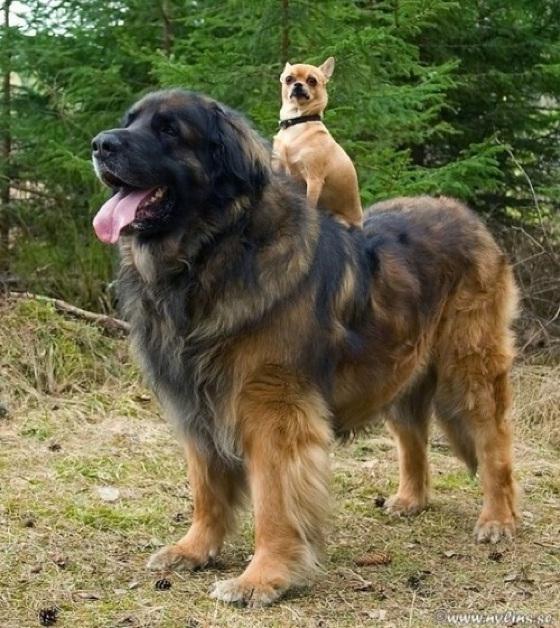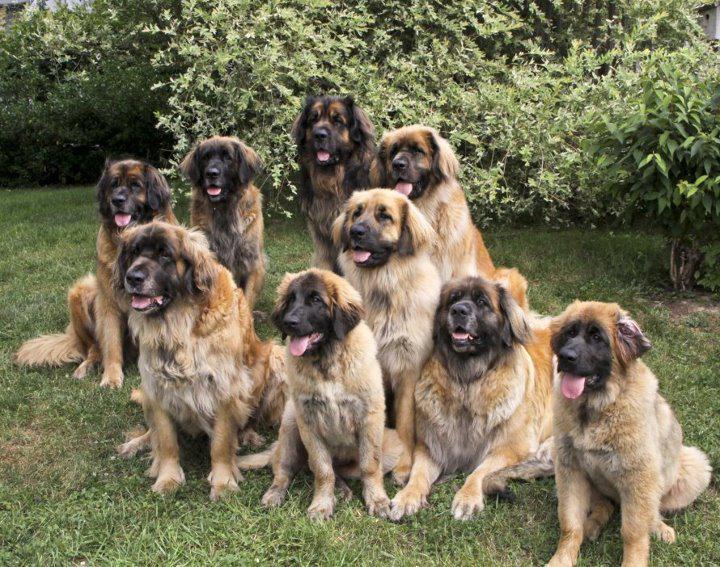The first image is the image on the left, the second image is the image on the right. Evaluate the accuracy of this statement regarding the images: "None of the dogs are alone and at least one of the dogs has a dark colored face.". Is it true? Answer yes or no. Yes. The first image is the image on the left, the second image is the image on the right. Assess this claim about the two images: "A group of dogs is in the grass in at least one picture.". Correct or not? Answer yes or no. Yes. 